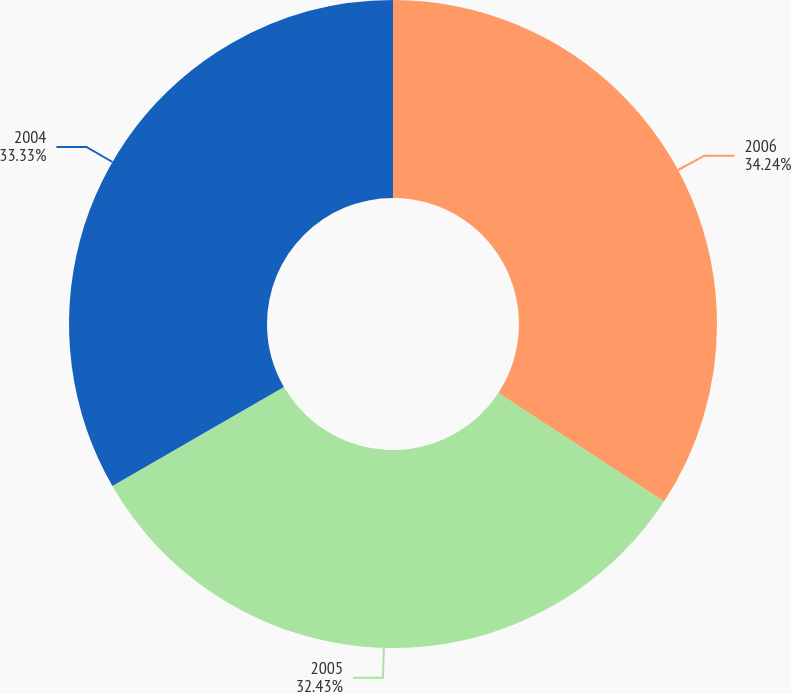Convert chart to OTSL. <chart><loc_0><loc_0><loc_500><loc_500><pie_chart><fcel>2006<fcel>2005<fcel>2004<nl><fcel>34.23%<fcel>32.43%<fcel>33.33%<nl></chart> 